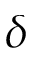<formula> <loc_0><loc_0><loc_500><loc_500>\delta</formula> 